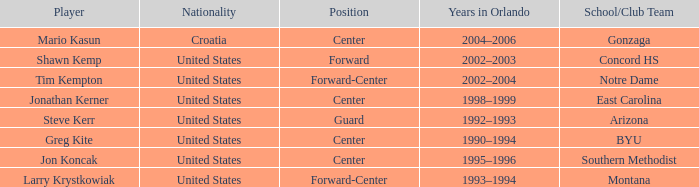Who is the player that belongs to the montana school/club team? Larry Krystkowiak. 